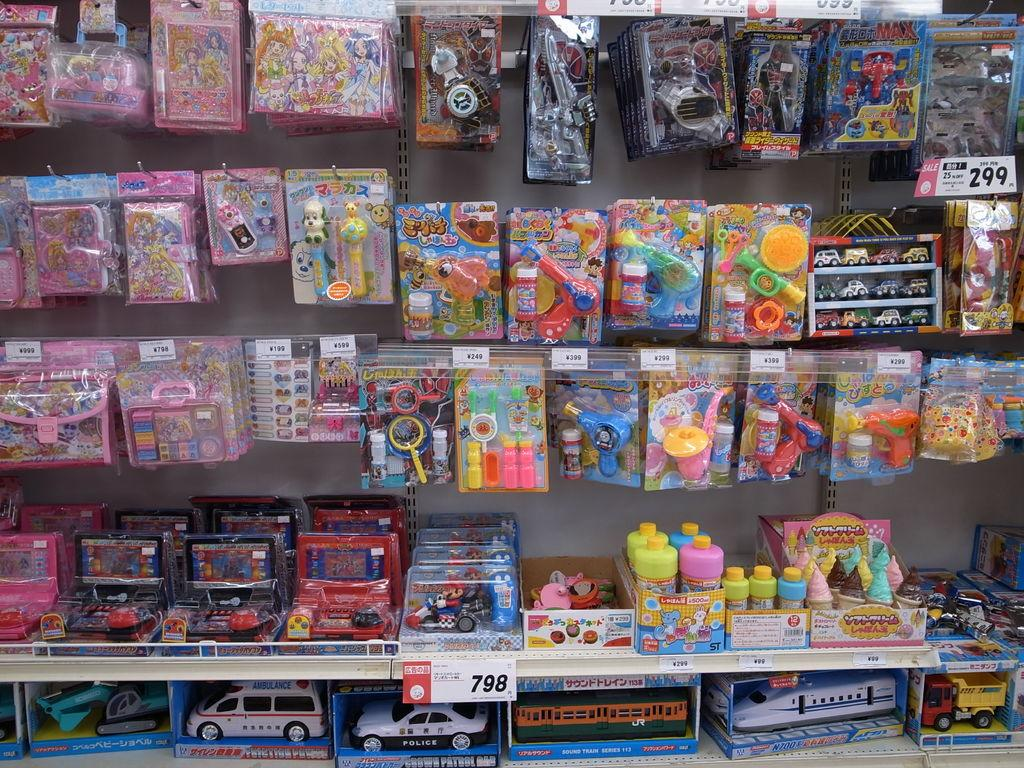<image>
Write a terse but informative summary of the picture. a toy isle with a price tag of 299 